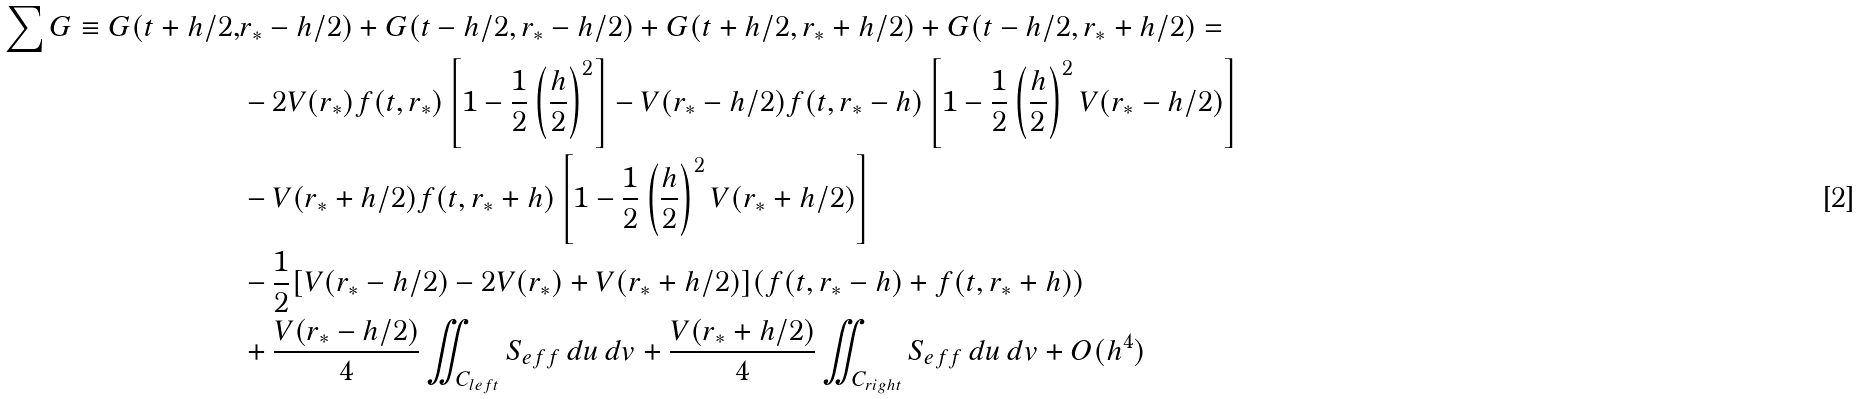Convert formula to latex. <formula><loc_0><loc_0><loc_500><loc_500>\sum G \equiv G ( t + h / 2 , & r _ { * } - h / 2 ) + G ( t - h / 2 , r _ { * } - h / 2 ) + G ( t + h / 2 , r _ { * } + h / 2 ) + G ( t - h / 2 , r _ { * } + h / 2 ) = \\ & - 2 V ( r _ { * } ) f ( t , r _ { * } ) \left [ 1 - \frac { 1 } { 2 } \left ( \frac { h } { 2 } \right ) ^ { 2 } \right ] - V ( r _ { * } - h / 2 ) f ( t , r _ { * } - h ) \left [ 1 - \frac { 1 } { 2 } \left ( \frac { h } { 2 } \right ) ^ { 2 } V ( r _ { * } - h / 2 ) \right ] \\ & - V ( r _ { * } + h / 2 ) f ( t , r _ { * } + h ) \left [ 1 - \frac { 1 } { 2 } \left ( \frac { h } { 2 } \right ) ^ { 2 } V ( r _ { * } + h / 2 ) \right ] \\ & - \frac { 1 } { 2 } [ V ( r _ { * } - h / 2 ) - 2 V ( r _ { * } ) + V ( r _ { * } + h / 2 ) ] ( f ( t , r _ { * } - h ) + f ( t , r _ { * } + h ) ) \\ & + \frac { V ( r _ { * } - h / 2 ) } { 4 } \iint _ { C _ { l e f t } } S _ { e f f } \, d u \, d v + \frac { V ( r _ { * } + h / 2 ) } { 4 } \iint _ { C _ { r i g h t } } S _ { e f f } \, d u \, d v + { O } ( h ^ { 4 } )</formula> 